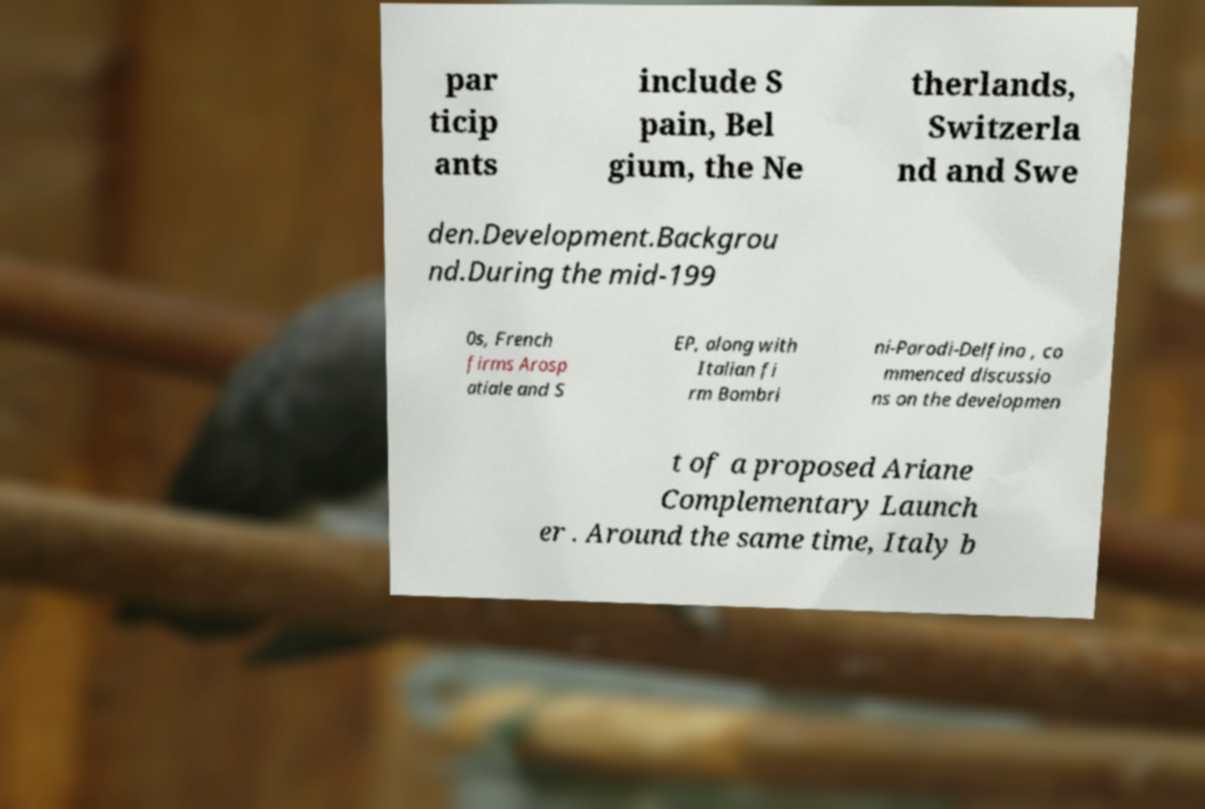Please read and relay the text visible in this image. What does it say? par ticip ants include S pain, Bel gium, the Ne therlands, Switzerla nd and Swe den.Development.Backgrou nd.During the mid-199 0s, French firms Arosp atiale and S EP, along with Italian fi rm Bombri ni-Parodi-Delfino , co mmenced discussio ns on the developmen t of a proposed Ariane Complementary Launch er . Around the same time, Italy b 